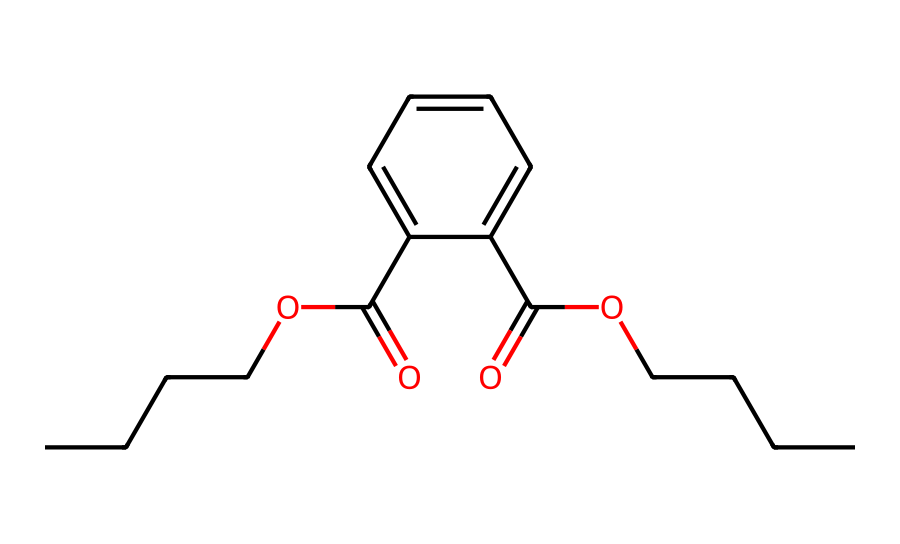What is the total number of carbon atoms in this structure? By analyzing the SMILES representation, we can identify the number of carbon (C) atoms present. Each "C" listed in the SMILES indicates a carbon atom. The entire structure has approximately 14 carbon atoms.
Answer: 14 How many ester functional groups are present in the chemical? The presence of the "O=C(O" notation in the SMILES indicates an ester functional group. Each occurrence of this suggests a separate ester. There are two instances of this grouping in the structure.
Answer: 2 What is the main product application of phthalates in this chemical? Phthalates are primarily known for their use as plasticizers in polyvinyl chloride (PVC) products, making them more flexible and durable.
Answer: plasticizers Which part of the structure indicates its aromatic nature? The presence of the "c" (lowercase) in the SMILES indicates that there are aromatic carbon atoms in the structure, particularly found within the phenyl rings. This confirms the aromatic nature of part of the structure.
Answer: aromatic ring What is the primary function of this compound in PVC products? The primary function of this compound in PVC products is to provide flexibility and softness, enhancing the material's usability in various applications.
Answer: flexibility What does the presence of the carboxylic acid groups indicate about the chemical? The "C(=O)O" segment represents carboxylic acid groups, which can imply that this compound may have acid-base properties, thereby affecting its interaction with other substances in PVC formulations.
Answer: acid-base properties 